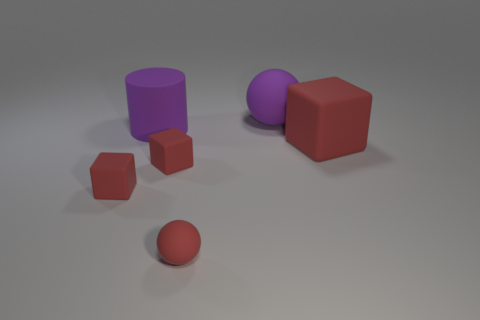Are there more matte balls in front of the large purple ball than tiny purple rubber spheres?
Your response must be concise. Yes. Is the tiny matte ball the same color as the large cube?
Keep it short and to the point. Yes. What number of other large objects are the same shape as the large red object?
Your answer should be compact. 0. There is a cylinder that is made of the same material as the large block; what is its size?
Your answer should be very brief. Large. What color is the object that is both left of the small rubber ball and behind the large block?
Provide a succinct answer. Purple. What number of matte cubes are the same size as the red sphere?
Keep it short and to the point. 2. What size is the thing that is the same color as the large cylinder?
Provide a short and direct response. Large. There is a red thing that is both on the left side of the small red sphere and right of the purple cylinder; what size is it?
Provide a short and direct response. Small. There is a rubber ball behind the rubber object right of the large matte sphere; what number of big purple cylinders are to the left of it?
Provide a succinct answer. 1. Is there a matte object of the same color as the small sphere?
Make the answer very short. Yes. 